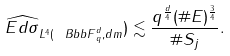<formula> <loc_0><loc_0><loc_500><loc_500>\| \widehat { E d \sigma } \| _ { L ^ { 4 } ( { \ B b b F } _ { q } ^ { d } , d m } ) \lesssim \frac { q ^ { \frac { d } { 4 } } ( \# E ) ^ { \frac { 3 } { 4 } } } { \# S _ { j } } .</formula> 